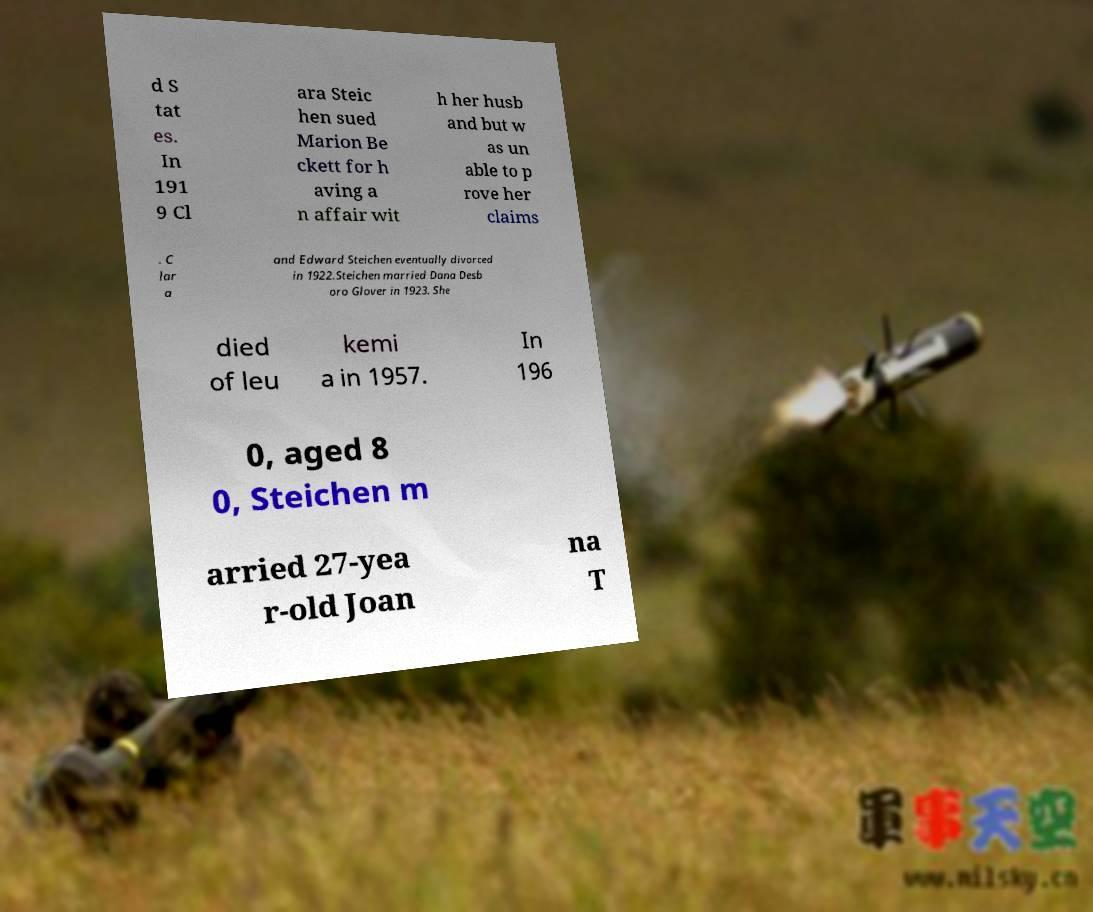Could you extract and type out the text from this image? d S tat es. In 191 9 Cl ara Steic hen sued Marion Be ckett for h aving a n affair wit h her husb and but w as un able to p rove her claims . C lar a and Edward Steichen eventually divorced in 1922.Steichen married Dana Desb oro Glover in 1923. She died of leu kemi a in 1957. In 196 0, aged 8 0, Steichen m arried 27-yea r-old Joan na T 